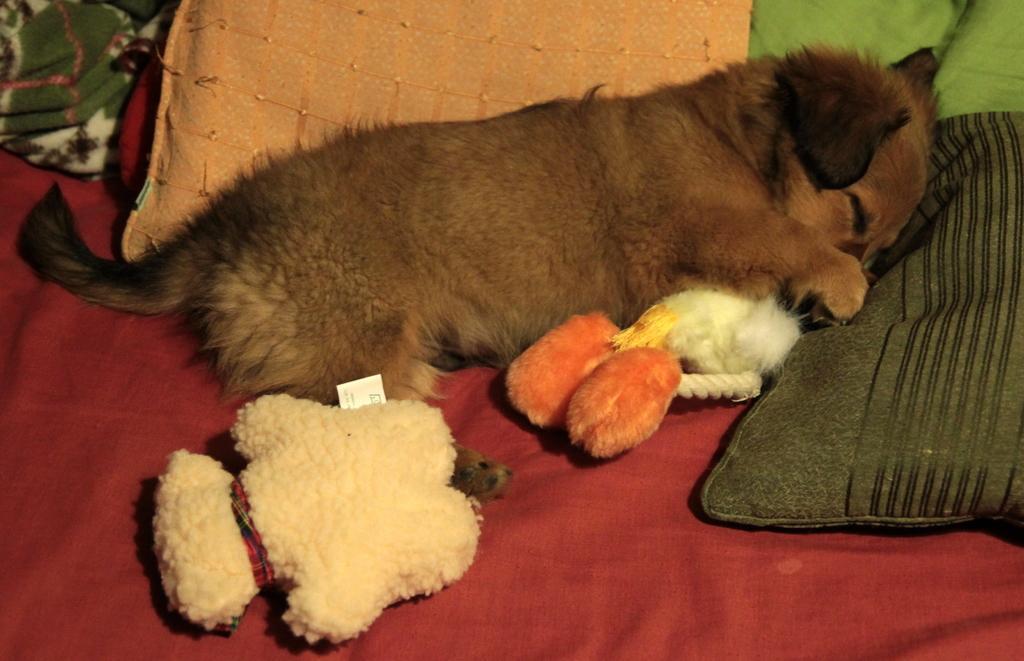Please provide a concise description of this image. In this image in the center there is one dog which is sleeping, beside the dog there are some toys and pillow it seems that the dog is sleeping on a bed. 